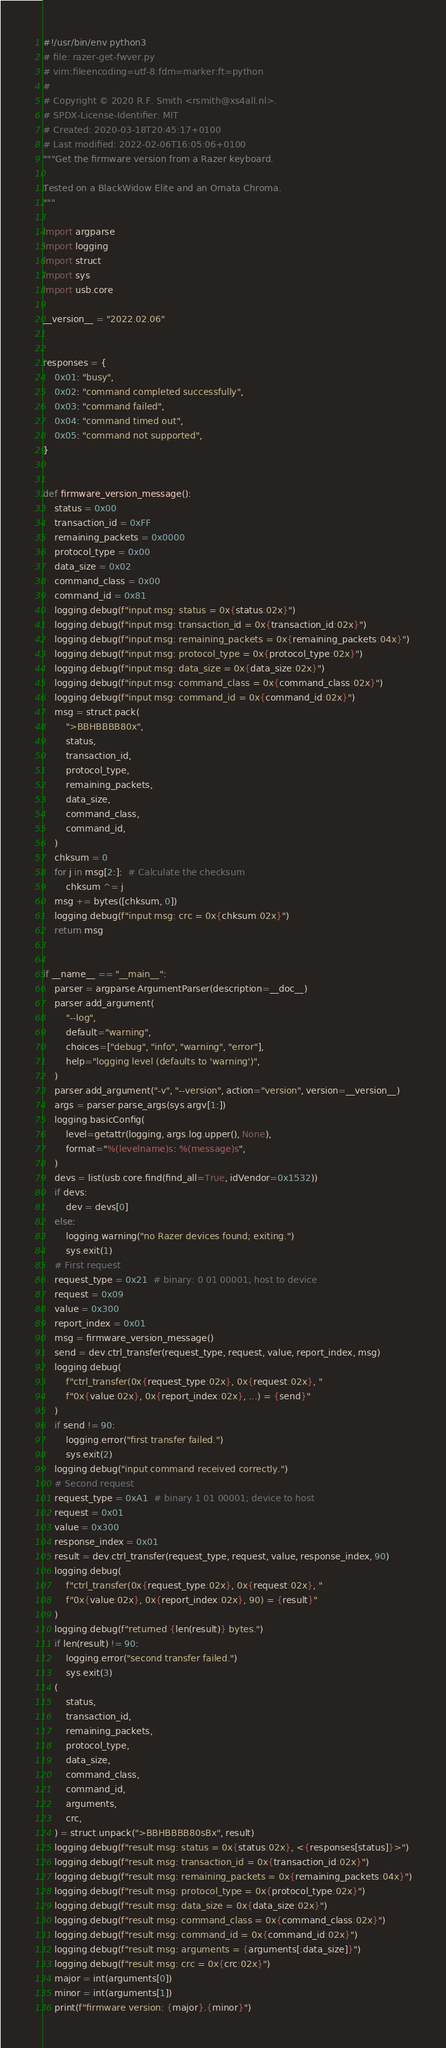<code> <loc_0><loc_0><loc_500><loc_500><_Python_>#!/usr/bin/env python3
# file: razer-get-fwver.py
# vim:fileencoding=utf-8:fdm=marker:ft=python
#
# Copyright © 2020 R.F. Smith <rsmith@xs4all.nl>.
# SPDX-License-Identifier: MIT
# Created: 2020-03-18T20:45:17+0100
# Last modified: 2022-02-06T16:05:06+0100
"""Get the firmware version from a Razer keyboard.

Tested on a BlackWidow Elite and an Ornata Chroma.
"""

import argparse
import logging
import struct
import sys
import usb.core

__version__ = "2022.02.06"


responses = {
    0x01: "busy",
    0x02: "command completed successfully",
    0x03: "command failed",
    0x04: "command timed out",
    0x05: "command not supported",
}


def firmware_version_message():
    status = 0x00
    transaction_id = 0xFF
    remaining_packets = 0x0000
    protocol_type = 0x00
    data_size = 0x02
    command_class = 0x00
    command_id = 0x81
    logging.debug(f"input msg: status = 0x{status:02x}")
    logging.debug(f"input msg: transaction_id = 0x{transaction_id:02x}")
    logging.debug(f"input msg: remaining_packets = 0x{remaining_packets:04x}")
    logging.debug(f"input msg: protocol_type = 0x{protocol_type:02x}")
    logging.debug(f"input msg: data_size = 0x{data_size:02x}")
    logging.debug(f"input msg: command_class = 0x{command_class:02x}")
    logging.debug(f"input msg: command_id = 0x{command_id:02x}")
    msg = struct.pack(
        ">BBHBBBB80x",
        status,
        transaction_id,
        protocol_type,
        remaining_packets,
        data_size,
        command_class,
        command_id,
    )
    chksum = 0
    for j in msg[2:]:  # Calculate the checksum
        chksum ^= j
    msg += bytes([chksum, 0])
    logging.debug(f"input msg: crc = 0x{chksum:02x}")
    return msg


if __name__ == "__main__":
    parser = argparse.ArgumentParser(description=__doc__)
    parser.add_argument(
        "--log",
        default="warning",
        choices=["debug", "info", "warning", "error"],
        help="logging level (defaults to 'warning')",
    )
    parser.add_argument("-v", "--version", action="version", version=__version__)
    args = parser.parse_args(sys.argv[1:])
    logging.basicConfig(
        level=getattr(logging, args.log.upper(), None),
        format="%(levelname)s: %(message)s",
    )
    devs = list(usb.core.find(find_all=True, idVendor=0x1532))
    if devs:
        dev = devs[0]
    else:
        logging.warning("no Razer devices found; exiting.")
        sys.exit(1)
    # First request
    request_type = 0x21  # binary: 0 01 00001; host to device
    request = 0x09
    value = 0x300
    report_index = 0x01
    msg = firmware_version_message()
    send = dev.ctrl_transfer(request_type, request, value, report_index, msg)
    logging.debug(
        f"ctrl_transfer(0x{request_type:02x}, 0x{request:02x}, "
        f"0x{value:02x}, 0x{report_index:02x}, ...) = {send}"
    )
    if send != 90:
        logging.error("first transfer failed.")
        sys.exit(2)
    logging.debug("input command received correctly.")
    # Second request
    request_type = 0xA1  # binary 1 01 00001; device to host
    request = 0x01
    value = 0x300
    response_index = 0x01
    result = dev.ctrl_transfer(request_type, request, value, response_index, 90)
    logging.debug(
        f"ctrl_transfer(0x{request_type:02x}, 0x{request:02x}, "
        f"0x{value:02x}, 0x{report_index:02x}, 90) = {result}"
    )
    logging.debug(f"returned {len(result)} bytes.")
    if len(result) != 90:
        logging.error("second transfer failed.")
        sys.exit(3)
    (
        status,
        transaction_id,
        remaining_packets,
        protocol_type,
        data_size,
        command_class,
        command_id,
        arguments,
        crc,
    ) = struct.unpack(">BBHBBBB80sBx", result)
    logging.debug(f"result msg: status = 0x{status:02x}, <{responses[status]}>")
    logging.debug(f"result msg: transaction_id = 0x{transaction_id:02x}")
    logging.debug(f"result msg: remaining_packets = 0x{remaining_packets:04x}")
    logging.debug(f"result msg: protocol_type = 0x{protocol_type:02x}")
    logging.debug(f"result msg: data_size = 0x{data_size:02x}")
    logging.debug(f"result msg: command_class = 0x{command_class:02x}")
    logging.debug(f"result msg: command_id = 0x{command_id:02x}")
    logging.debug(f"result msg: arguments = {arguments[:data_size]}")
    logging.debug(f"result msg: crc = 0x{crc:02x}")
    major = int(arguments[0])
    minor = int(arguments[1])
    print(f"firmware version: {major}.{minor}")
</code> 